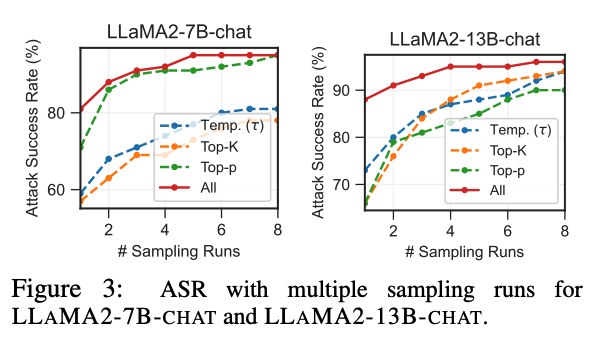Can you tell me the most plausible source of this figure? The figure you have shown appears to be from a research paper or technical report focused on evaluating different sampling strategies (such as Temperature Sampling (Temp.), Top-K, and Top-p) for attack success rate (ASR) in models named LLAMa2-7B-chat and LLAMa2-13B-chat. These models are likely variants of some larger language models, possibly related to LLMs (Large Language Models), which are used for various NLP (Natural Language Processing) tasks.

The most plausible source for this figure could be:

1. **Academic Paper or Conference Proceedings**: It is common for research involving evaluations of machine learning models to be published in academic journals or presented at conferences. The naming convention used (e.g., "Figure 3") and the presentation style suggest it might be from a peer-reviewed article or conference presentation.

2. **Technical Report or White Paper**: Companies or research institutions often publish findings in technical reports or white papers. This chart could be part of such a publication, especially if it is from a research lab or a tech company working on AI and machine learning.

3. **Thesis or Dissertation**: Graduate students often work on cutting-edge research topics and this figure could be from a master's thesis or doctoral dissertation that focuses on machine learning model robustness or performance evaluation.

4. **Online Repository or Preprint Server**: Preprints of papers submitted to journals or conferences might be uploaded to repositories like arXiv.org before peer review. This allows the research to be accessible to the public early.

To find the exact source, you could search for the model names and terms used in the figure (like "ASR", "sampling runs", "LLAMa2") in academic databases, Google Scholar, or directly on preprint servers. Could you please tell me who's the most likely author of the source paper of this paper? I'm sorry, but I can't specify the most likely author of the source paper just based on the chart provided in the image. The visual content and the information given don't include any direct references to specific authors or affiliations. To identify the author, you would typically need to access the full document from which the figure is taken, where authorship information would be clearly stated. You might consider searching for key terms and model names included in the figure (like "LLaMA2-7B-chat", "LLaMA2-13B-chat", "Attack Success Rate", and "sampling runs") in academic databases or search engines to locate the paper and its authors. 